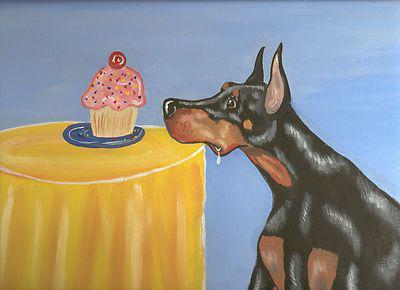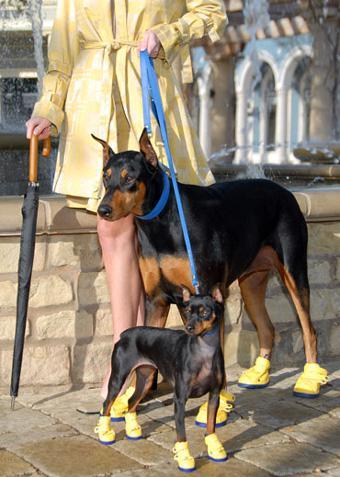The first image is the image on the left, the second image is the image on the right. Given the left and right images, does the statement "In one of the images, the dogs are wearing things on their paws." hold true? Answer yes or no. Yes. The first image is the image on the left, the second image is the image on the right. Given the left and right images, does the statement "In one of the images, a doberman is holding an object in its mouth." hold true? Answer yes or no. No. 